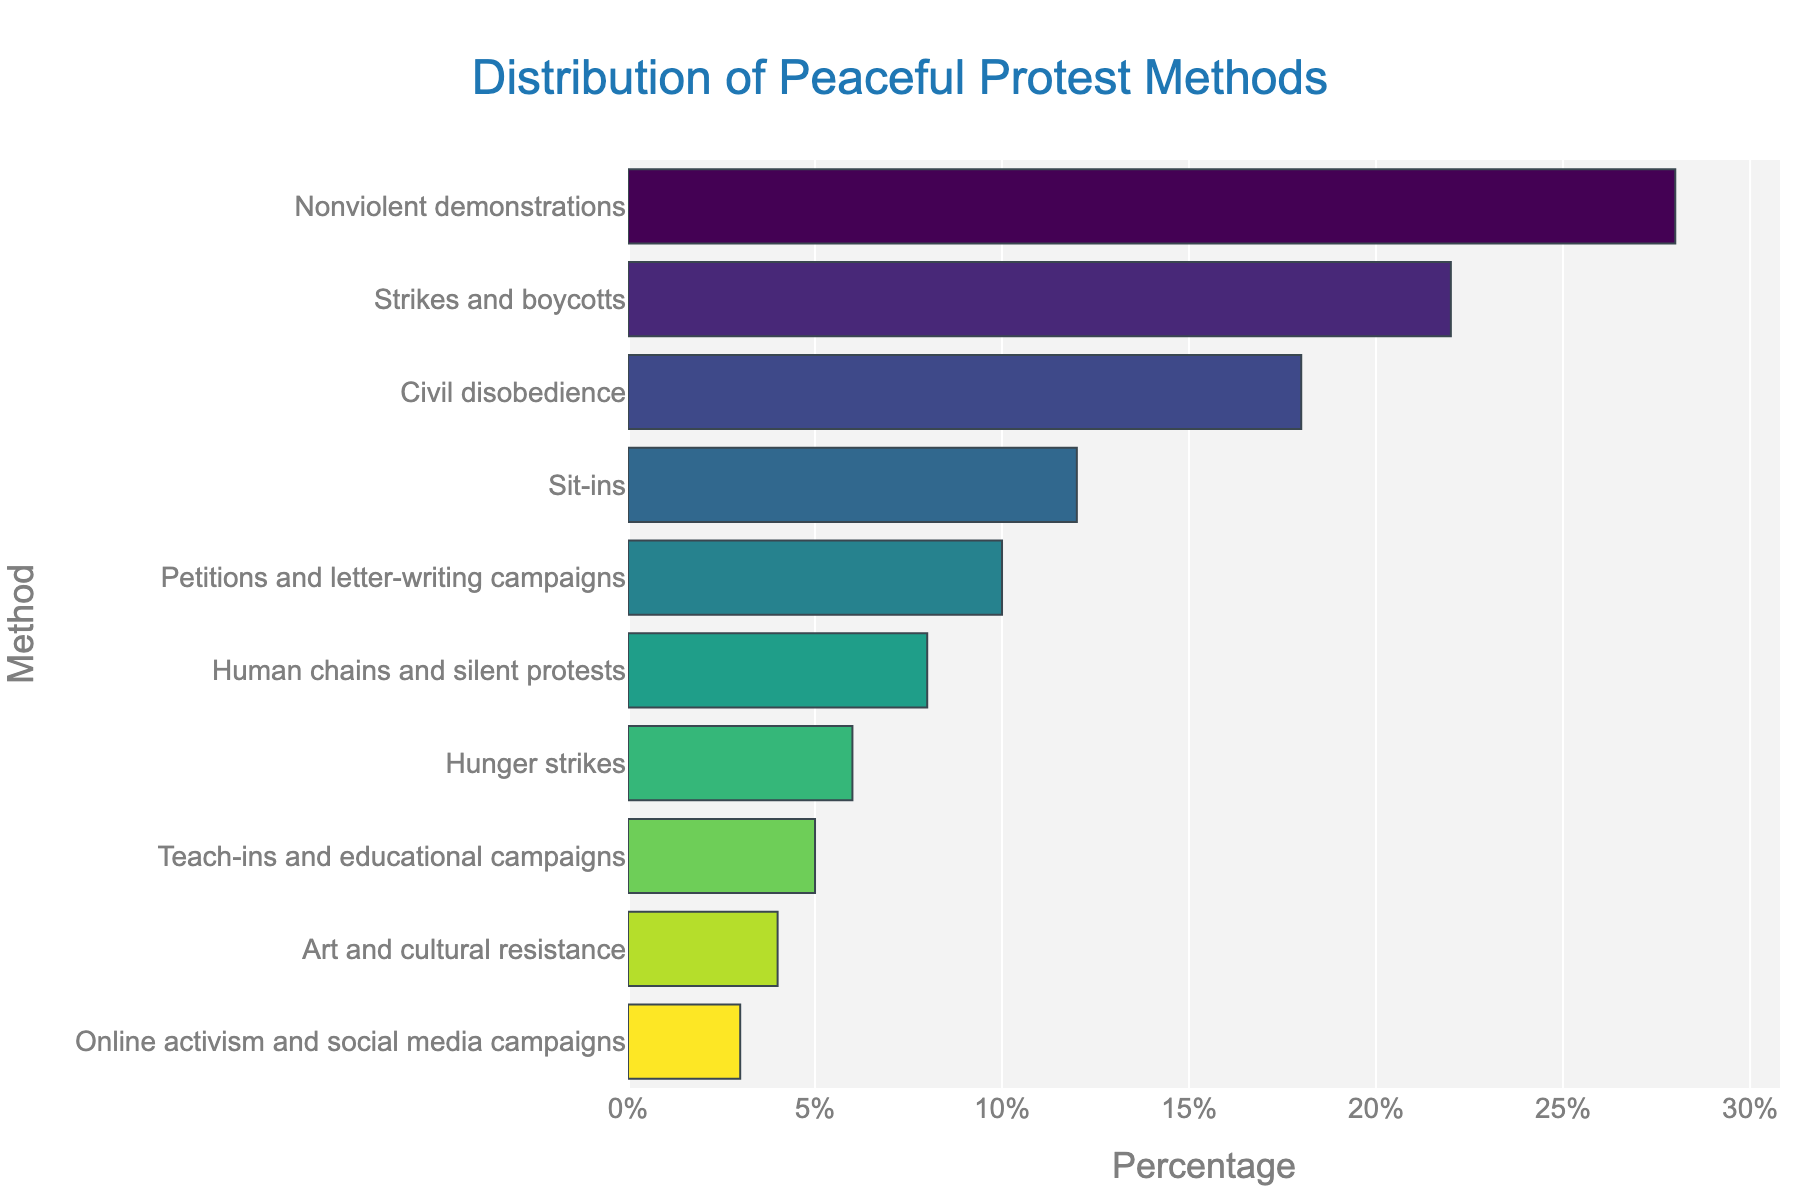What is the most common method of peaceful protest according to the figure? The figure shows a horizontal bar chart with 'Percentage' on the x-axis and 'Method' on the y-axis. The tallest bar, representing the highest percentage, is labeled 'Nonviolent demonstrations', indicating it is the most common method.
Answer: Nonviolent demonstrations Which method of peaceful protest is used least frequently? The smallest bar in the chart corresponds to 'Online activism and social media campaigns', with only a 3% usage rate.
Answer: Online activism and social media campaigns What is the combined percentage of 'Sit-ins' and 'Petitions and letter-writing campaigns'? To find this, locate the bars for 'Sit-ins' and 'Petitions and letter-writing campaigns'. According to the chart, they are 12% and 10% respectively. Adding these two values, 12 + 10, gives a total combined percentage.
Answer: 22% Is 'Civil disobedience' more commonly used than 'Strikes and boycotts'? By how much? By identifying the bars for 'Civil disobedience' and 'Strikes and boycotts', you can see 'Strikes and boycotts' is 22% and 'Civil disobedience' is 18%. Subtracting these two values, 22 - 18, shows that 'Strikes and boycotts' are more common by 4%.
Answer: No, 4% What is the average percentage of the three least frequently used methods? The three least frequently used methods are 'Online activism and social media campaigns' (3%), 'Art and cultural resistance' (4%), and 'Teach-ins and educational campaigns' (5%). To find the average, sum these percentages (3 + 4 + 5 = 12), then divide by the number of methods (3).
Answer: 4% Which methods have a percentage greater than 20%? According to the chart, the methods with bars extending beyond the 20% mark are 'Nonviolent demonstrations' (28%) and 'Strikes and boycotts' (22%).
Answer: Nonviolent demonstrations, Strikes and boycotts How does the height of the bar for 'Hunger strikes' compare to that of 'Nonviolent demonstrations'? Visually, the bar for 'Hunger strikes' is much shorter than that for 'Nonviolent demonstrations'. Specifically, 'Hunger strikes' is at 6%, while 'Nonviolent demonstrations' stands tall at 28%.
Answer: Much shorter What is the range of percentages covered by the methods shown in the figure? The range is calculated by subtracting the smallest percentage value from the largest. The smallest percentage is 3% ('Online activism and social media campaigns'), and the largest is 28% ('Nonviolent demonstrations'). So, 28 - 3 equals 25.
Answer: 25% What is the sum of the percentages of all methods used? To find the total, each percentage value from the chart is summed: 28 (Nonviolent demonstrations) + 22 (Strikes and boycotts) + 18 (Civil disobedience) + 12 (Sit-ins) + 10 (Petitions and letter-writing campaigns) + 8 (Human chains and silent protests) + 6 (Hunger strikes) + 5 (Teach-ins and educational campaigns) + 4 (Art and cultural resistance) + 3 (Online activism and social media campaigns). This totals to 116%.
Answer: 116% Which method of peaceful protest has a similar percentage to 'Civil disobedience'? 'Strikes and boycotts' have a comparable percentage to 'Civil disobedience', with 'Strikes and boycotts' at 22% and 'Civil disobedience' at 18%. Both are higher proportions in the chart but not exactly the same.
Answer: Strikes and boycotts 